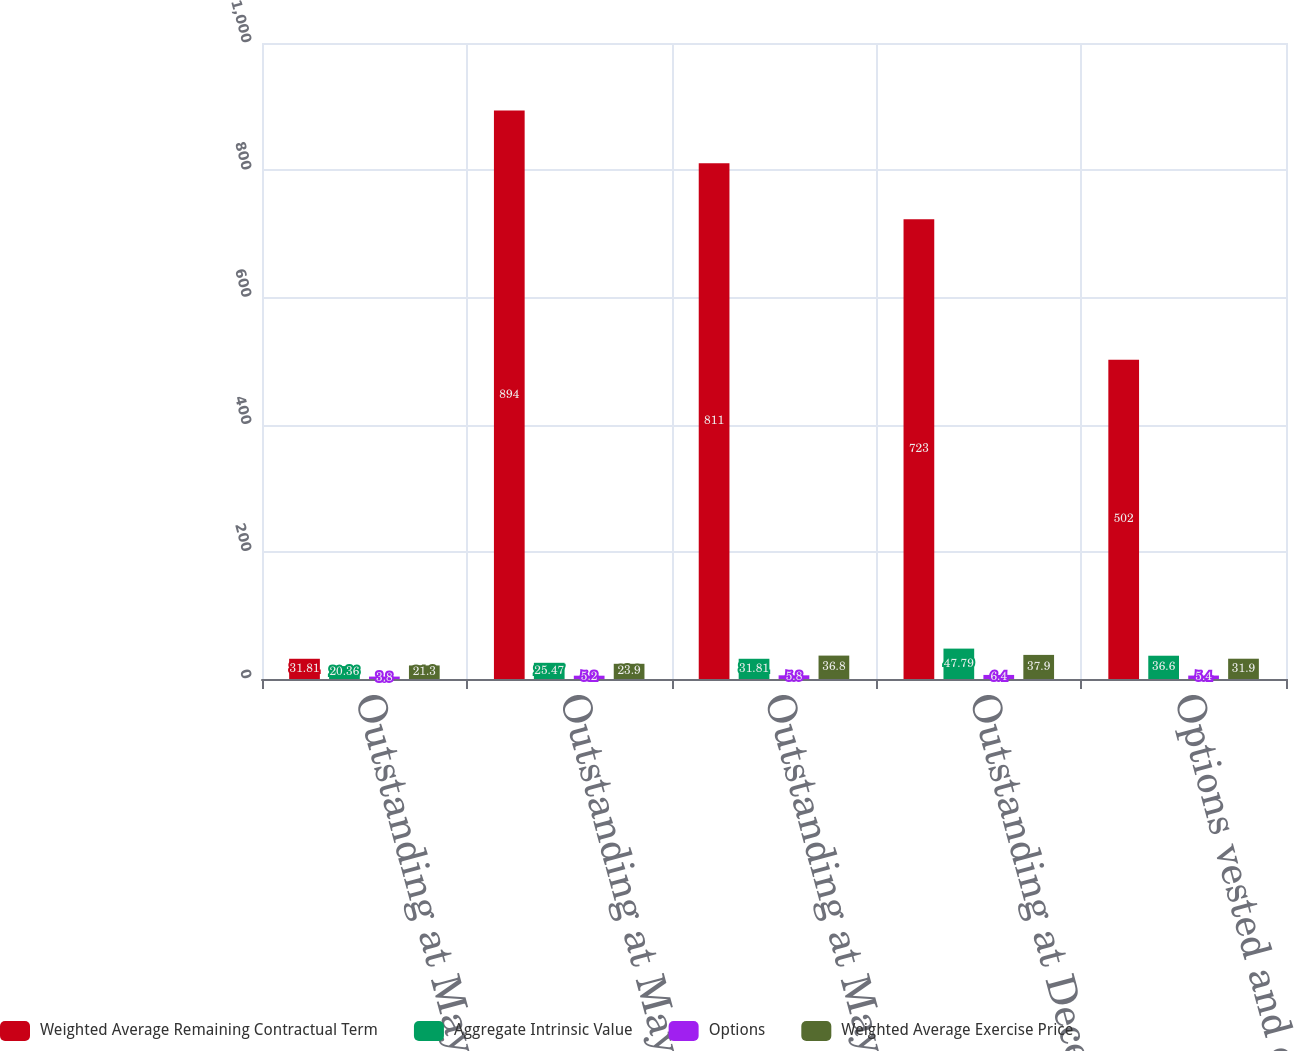Convert chart. <chart><loc_0><loc_0><loc_500><loc_500><stacked_bar_chart><ecel><fcel>Outstanding at May 31 2014<fcel>Outstanding at May 31 2015<fcel>Outstanding at May 31 2016<fcel>Outstanding at December 31<fcel>Options vested and exercisable<nl><fcel>Weighted Average Remaining Contractual Term<fcel>31.81<fcel>894<fcel>811<fcel>723<fcel>502<nl><fcel>Aggregate Intrinsic Value<fcel>20.36<fcel>25.47<fcel>31.81<fcel>47.79<fcel>36.6<nl><fcel>Options<fcel>3.8<fcel>5.2<fcel>5.8<fcel>6.4<fcel>5.4<nl><fcel>Weighted Average Exercise Price<fcel>21.3<fcel>23.9<fcel>36.8<fcel>37.9<fcel>31.9<nl></chart> 